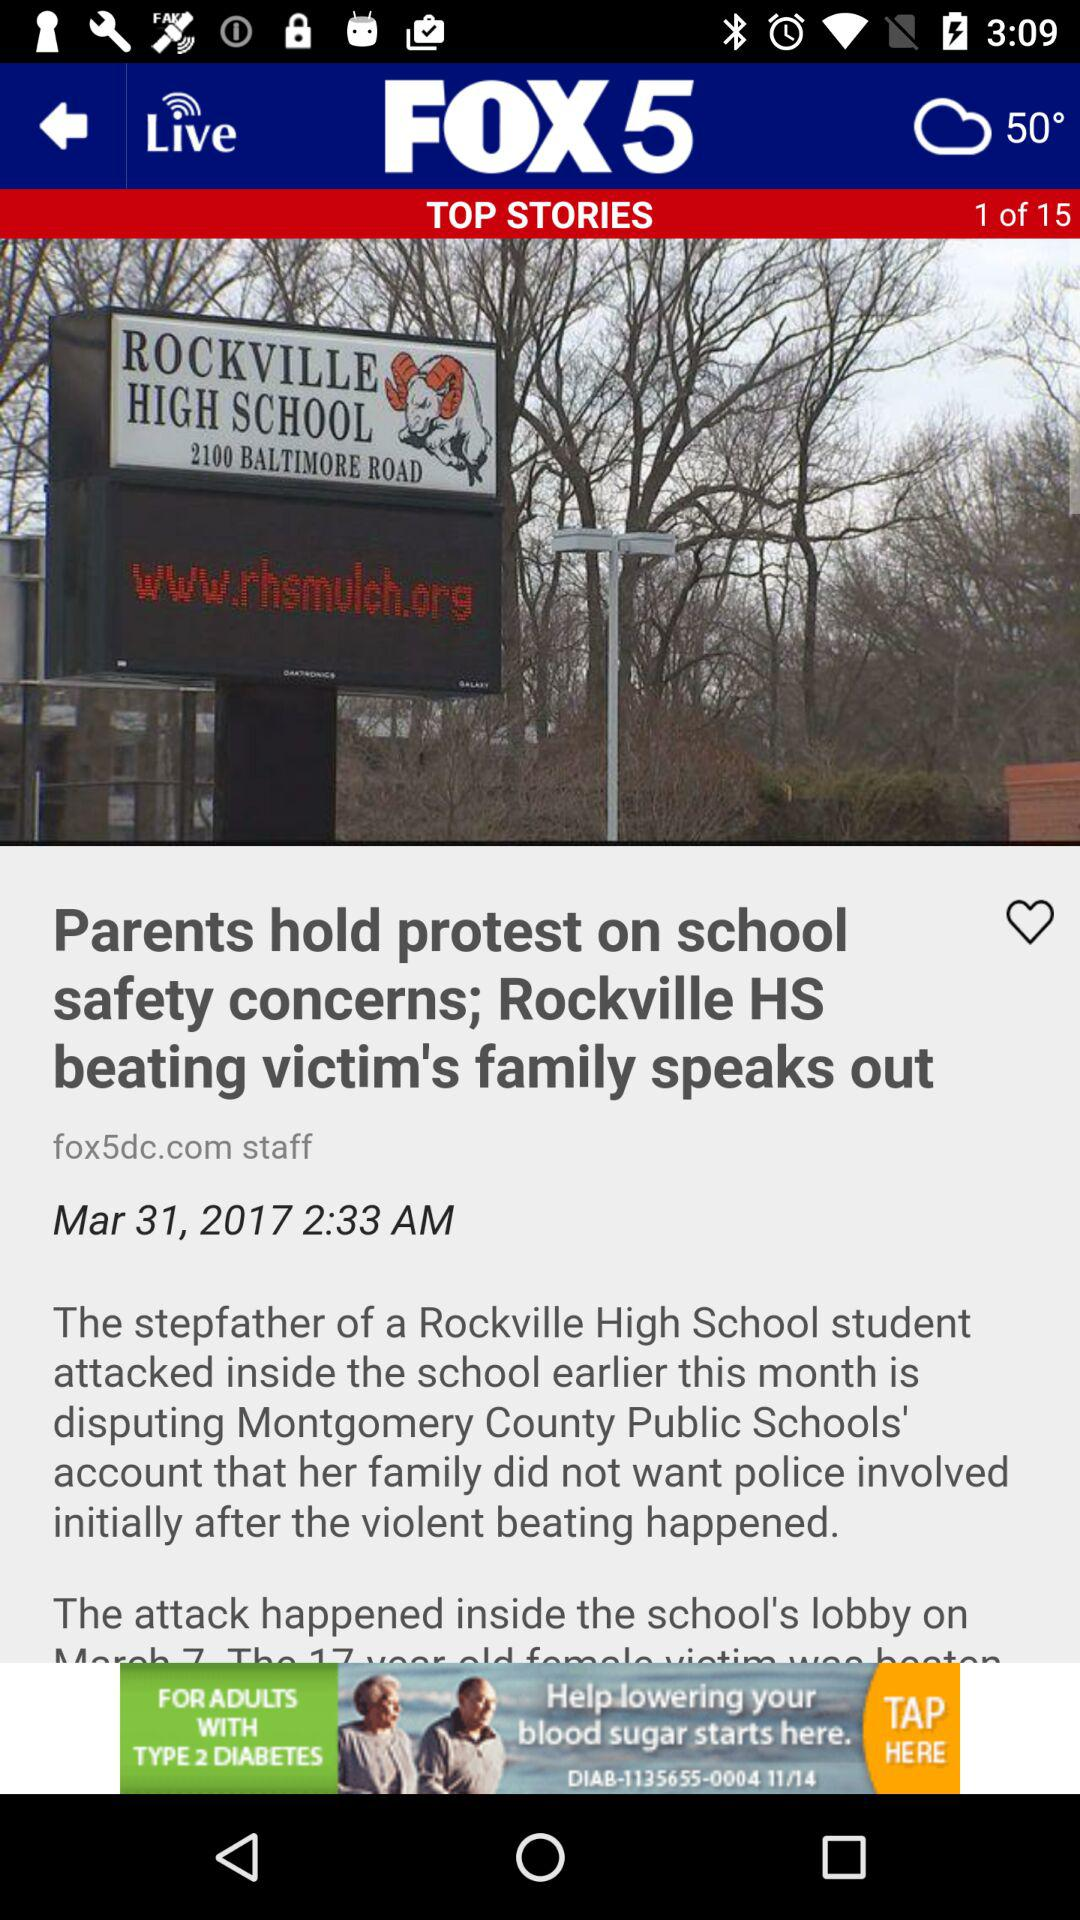Which story am I on? You are on story 1. 